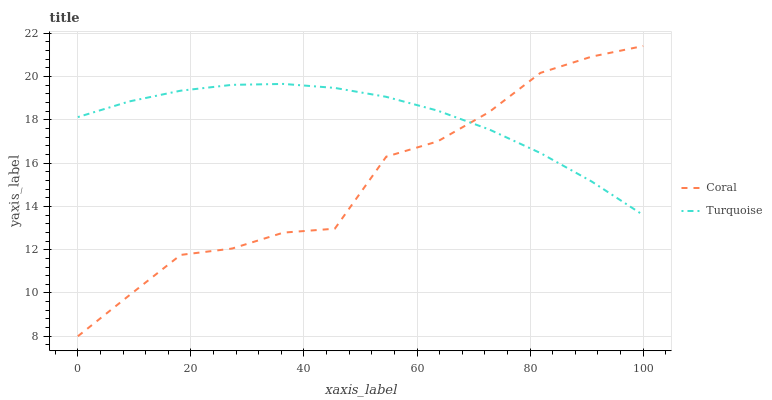Does Coral have the minimum area under the curve?
Answer yes or no. Yes. Does Turquoise have the maximum area under the curve?
Answer yes or no. Yes. Does Turquoise have the minimum area under the curve?
Answer yes or no. No. Is Turquoise the smoothest?
Answer yes or no. Yes. Is Coral the roughest?
Answer yes or no. Yes. Is Turquoise the roughest?
Answer yes or no. No. Does Coral have the lowest value?
Answer yes or no. Yes. Does Turquoise have the lowest value?
Answer yes or no. No. Does Coral have the highest value?
Answer yes or no. Yes. Does Turquoise have the highest value?
Answer yes or no. No. Does Turquoise intersect Coral?
Answer yes or no. Yes. Is Turquoise less than Coral?
Answer yes or no. No. Is Turquoise greater than Coral?
Answer yes or no. No. 